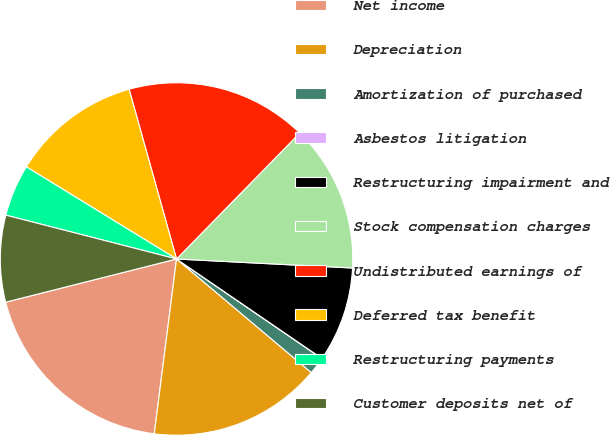<chart> <loc_0><loc_0><loc_500><loc_500><pie_chart><fcel>Net income<fcel>Depreciation<fcel>Amortization of purchased<fcel>Asbestos litigation<fcel>Restructuring impairment and<fcel>Stock compensation charges<fcel>Undistributed earnings of<fcel>Deferred tax benefit<fcel>Restructuring payments<fcel>Customer deposits net of<nl><fcel>19.04%<fcel>15.87%<fcel>1.59%<fcel>0.01%<fcel>8.73%<fcel>13.49%<fcel>16.66%<fcel>11.9%<fcel>4.76%<fcel>7.94%<nl></chart> 